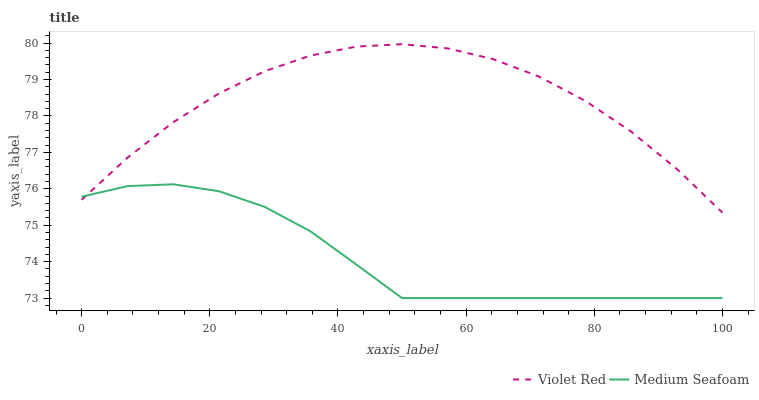Does Medium Seafoam have the minimum area under the curve?
Answer yes or no. Yes. Does Violet Red have the maximum area under the curve?
Answer yes or no. Yes. Does Medium Seafoam have the maximum area under the curve?
Answer yes or no. No. Is Medium Seafoam the smoothest?
Answer yes or no. Yes. Is Violet Red the roughest?
Answer yes or no. Yes. Is Medium Seafoam the roughest?
Answer yes or no. No. Does Medium Seafoam have the lowest value?
Answer yes or no. Yes. Does Violet Red have the highest value?
Answer yes or no. Yes. Does Medium Seafoam have the highest value?
Answer yes or no. No. Does Violet Red intersect Medium Seafoam?
Answer yes or no. Yes. Is Violet Red less than Medium Seafoam?
Answer yes or no. No. Is Violet Red greater than Medium Seafoam?
Answer yes or no. No. 